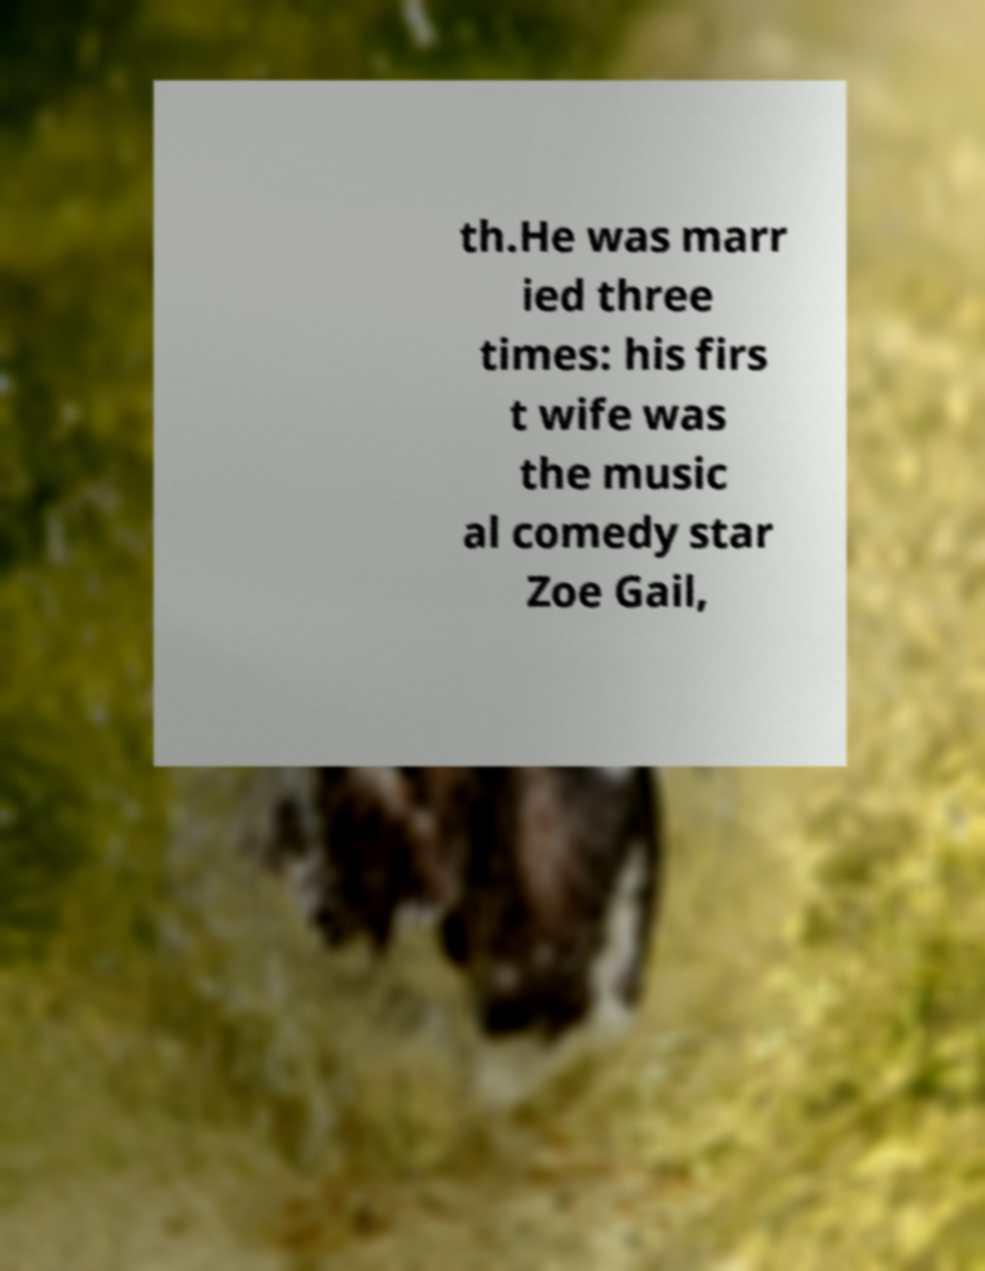Please read and relay the text visible in this image. What does it say? th.He was marr ied three times: his firs t wife was the music al comedy star Zoe Gail, 